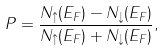<formula> <loc_0><loc_0><loc_500><loc_500>P = \frac { N _ { \uparrow } ( E _ { F } ) - N _ { \downarrow } ( E _ { F } ) } { N _ { \uparrow } ( E _ { F } ) + N _ { \downarrow } ( E _ { F } ) } ,</formula> 